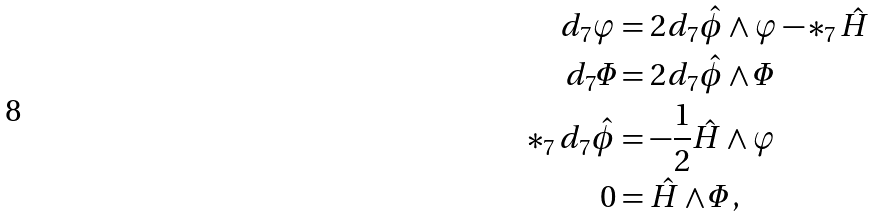<formula> <loc_0><loc_0><loc_500><loc_500>d _ { 7 } \varphi & = 2 d _ { 7 } \hat { \phi } \wedge \varphi - * _ { 7 } \, \hat { H } \\ d _ { 7 } \varPhi & = 2 d _ { 7 } \hat { \phi } \wedge \varPhi \\ * _ { 7 } \, d _ { 7 } \hat { \phi } & = - \frac { 1 } { 2 } \hat { H } \wedge \varphi \\ 0 & = \hat { H } \wedge \varPhi \, ,</formula> 